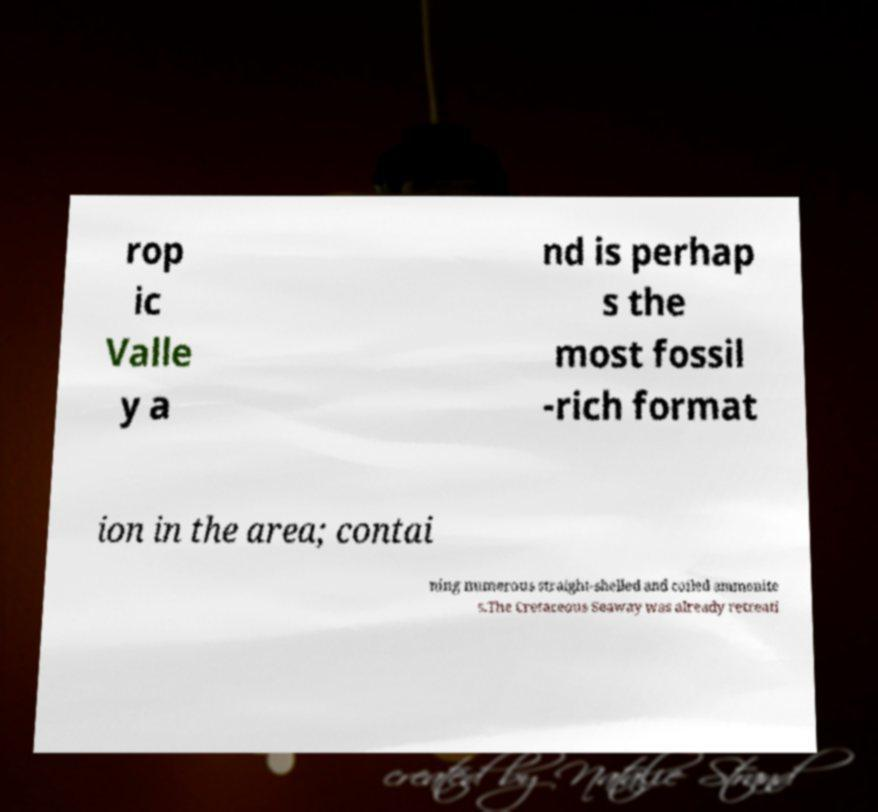Could you assist in decoding the text presented in this image and type it out clearly? rop ic Valle y a nd is perhap s the most fossil -rich format ion in the area; contai ning numerous straight-shelled and coiled ammonite s.The Cretaceous Seaway was already retreati 